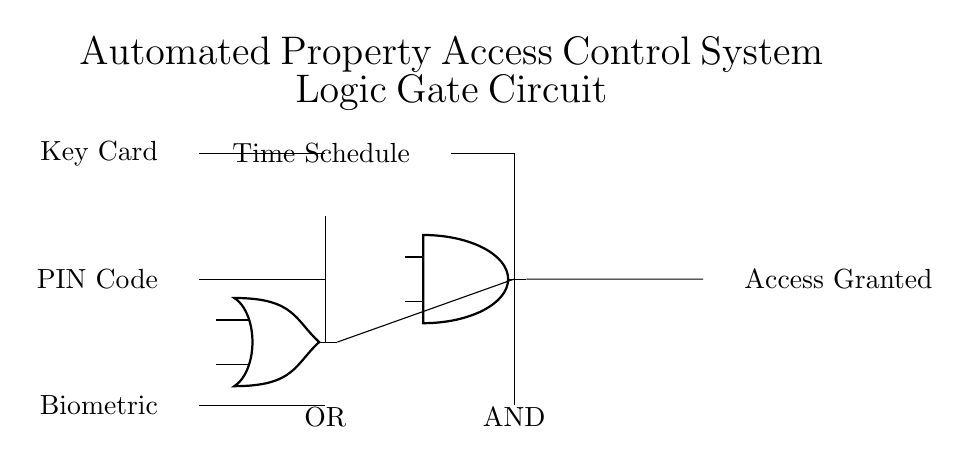What are the input signals in this circuit? The input signals shown in the circuit diagram are Key Card, PIN Code, and Biometric. These are indicated near the left side of the circuit.
Answer: Key Card, PIN Code, Biometric What is the type of the first logic gate in the circuit? The first logic gate depicted in the circuit diagram is an OR gate, which processes multiple inputs and produces an output if at least one input is true. It is located between the input signals and the AND gate.
Answer: OR What is the output of the circuit? The output of the circuit, indicated on the far right side, is Access Granted. This signifies the result of the logical operations performed by the gates in response to the input signals.
Answer: Access Granted Which input signal is combined with the Time Schedule? The input signal combined with the Time Schedule is the output from the AND gate. The diagram shows that the AND gate takes inputs from the OR gate and the Time Schedule to determine the final output.
Answer: Time Schedule How many logic gates are used in the circuit? The circuit contains two logic gates - one OR gate and one AND gate. Each gate is critical for the logical operations that determine access based on the input signals.
Answer: Two What does the AND gate signify in the circuit's operation? The AND gate signifies that to grant access, all conditions represented by its inputs must be satisfied. In this circuit, this includes the output from the OR gate and the additional Time Schedule.
Answer: All conditions must be true What does an OR gate do in this circuit context? In this circuit, the OR gate allows for access if at least one of its input conditions (Key Card, PIN Code, or Biometric) is met, simplifying the access protocol for users.
Answer: Allows access if at least one input is true 